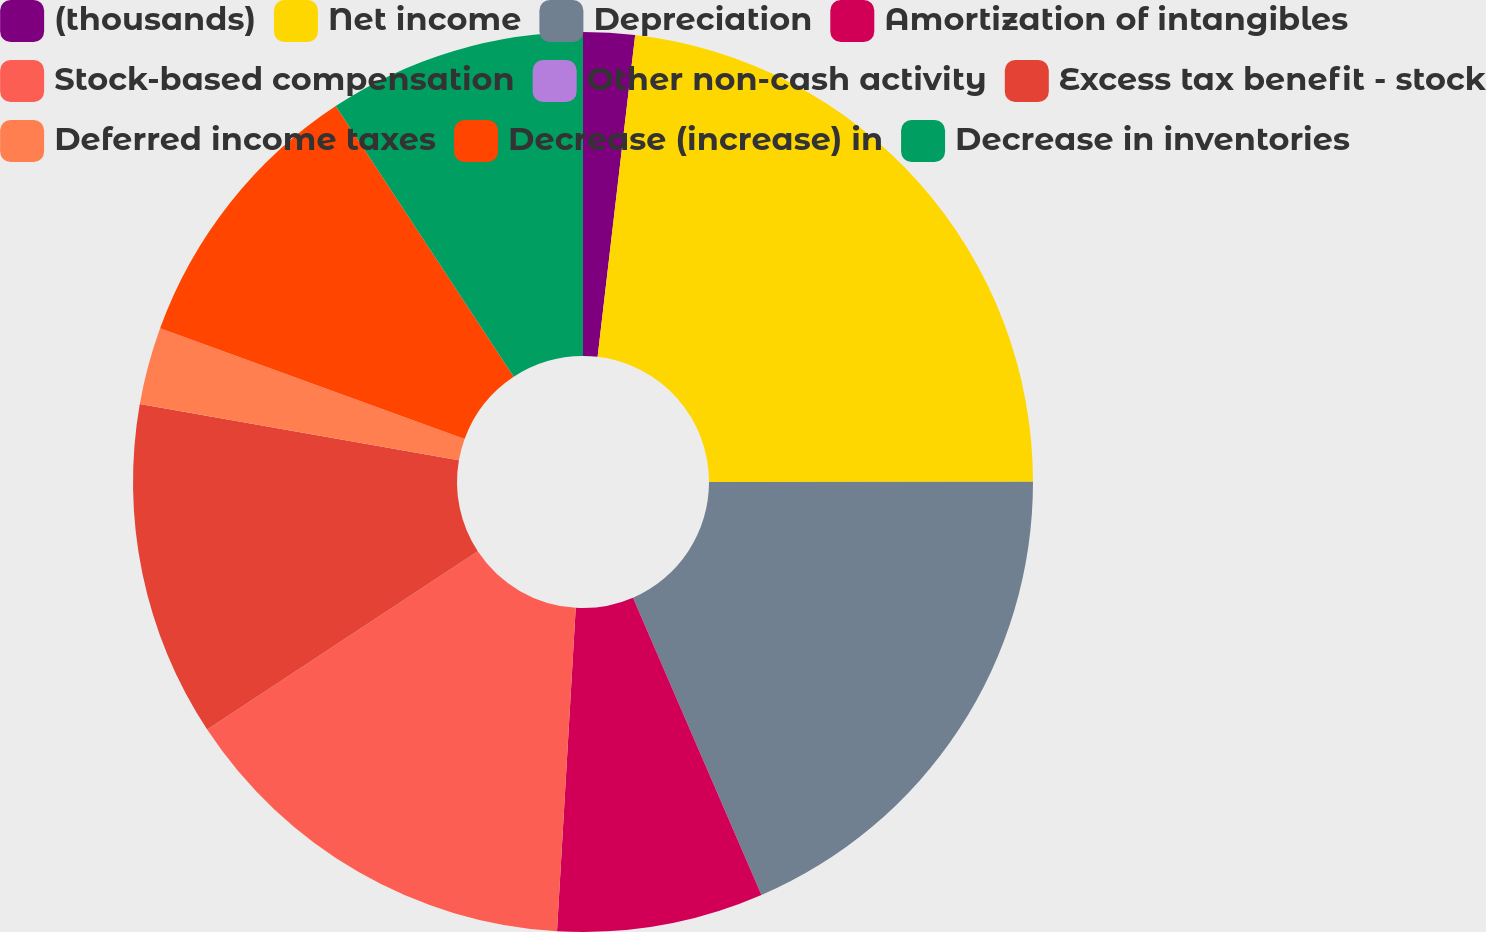Convert chart. <chart><loc_0><loc_0><loc_500><loc_500><pie_chart><fcel>(thousands)<fcel>Net income<fcel>Depreciation<fcel>Amortization of intangibles<fcel>Stock-based compensation<fcel>Other non-cash activity<fcel>Excess tax benefit - stock<fcel>Deferred income taxes<fcel>Decrease (increase) in<fcel>Decrease in inventories<nl><fcel>1.85%<fcel>23.14%<fcel>18.52%<fcel>7.41%<fcel>14.81%<fcel>0.0%<fcel>12.04%<fcel>2.78%<fcel>10.19%<fcel>9.26%<nl></chart> 